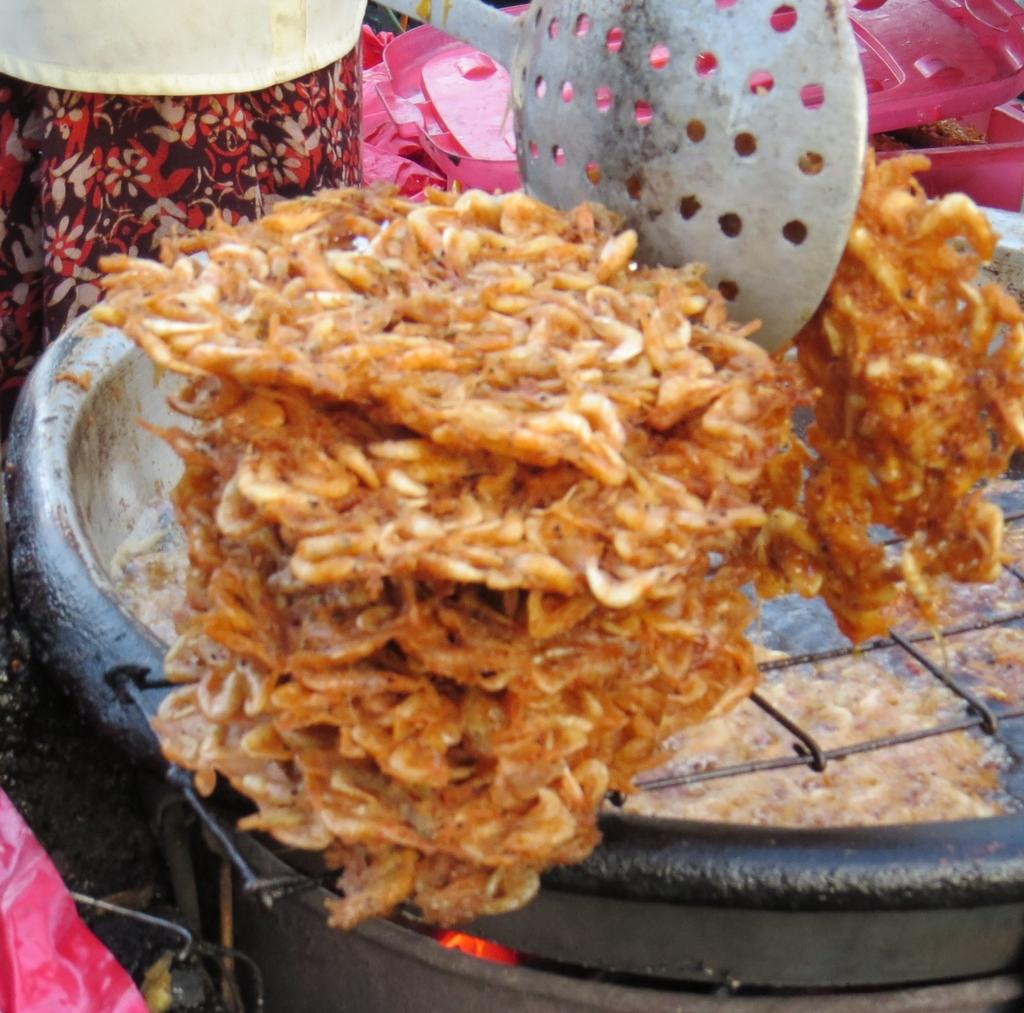What is being cooked on the grill in the image? There is food on the grill in the image. What can be seen in the background of the image? There is a dress and pink color objects visible in the background of the image. What type of utensil is present in the image? There is an ash color spoon in the image. What time of day is the surprise party taking place in the image? There is no indication of a surprise party or any specific time of day in the image. 